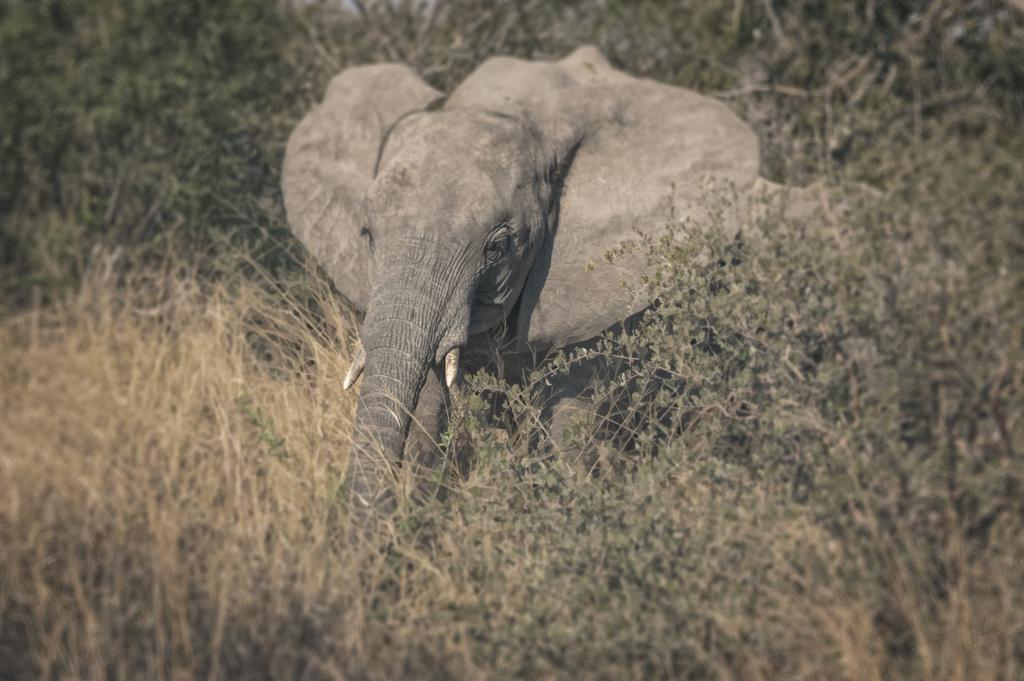What animal is the main subject of the picture? There is an elephant in the picture. What can be seen in the background of the picture? There are trees in the background of the picture. What type of language is the elephant speaking in the image? Elephants do not speak human languages, and there is no indication in the image that the elephant is speaking any language. 